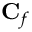Convert formula to latex. <formula><loc_0><loc_0><loc_500><loc_500>C _ { f }</formula> 